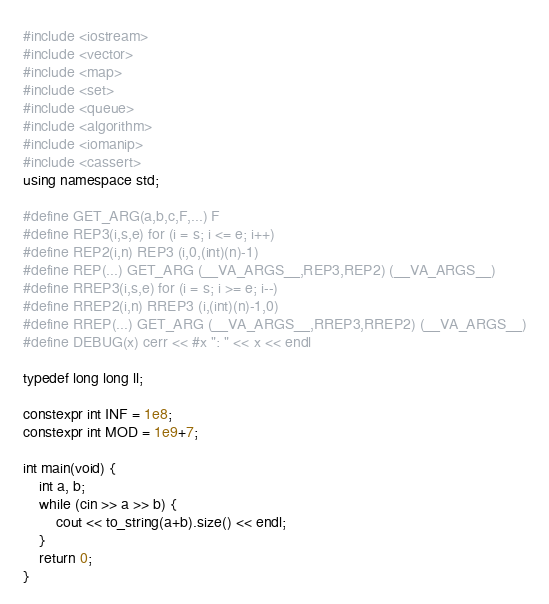Convert code to text. <code><loc_0><loc_0><loc_500><loc_500><_C++_>#include <iostream>
#include <vector>
#include <map>
#include <set>
#include <queue>
#include <algorithm>
#include <iomanip>
#include <cassert>
using namespace std;

#define GET_ARG(a,b,c,F,...) F
#define REP3(i,s,e) for (i = s; i <= e; i++)
#define REP2(i,n) REP3 (i,0,(int)(n)-1)
#define REP(...) GET_ARG (__VA_ARGS__,REP3,REP2) (__VA_ARGS__)
#define RREP3(i,s,e) for (i = s; i >= e; i--)
#define RREP2(i,n) RREP3 (i,(int)(n)-1,0)
#define RREP(...) GET_ARG (__VA_ARGS__,RREP3,RREP2) (__VA_ARGS__)
#define DEBUG(x) cerr << #x ": " << x << endl

typedef long long ll;

constexpr int INF = 1e8;
constexpr int MOD = 1e9+7;

int main(void) {
    int a, b;
    while (cin >> a >> b) {
        cout << to_string(a+b).size() << endl;
    }
    return 0;
}</code> 